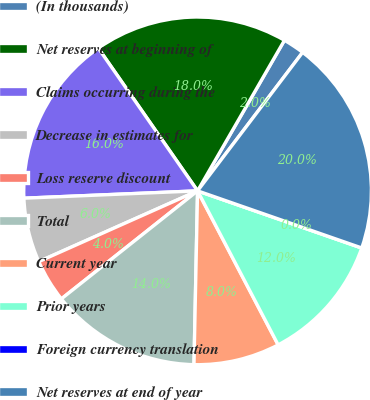Convert chart to OTSL. <chart><loc_0><loc_0><loc_500><loc_500><pie_chart><fcel>(In thousands)<fcel>Net reserves at beginning of<fcel>Claims occurring during the<fcel>Decrease in estimates for<fcel>Loss reserve discount<fcel>Total<fcel>Current year<fcel>Prior years<fcel>Foreign currency translation<fcel>Net reserves at end of year<nl><fcel>2.0%<fcel>18.0%<fcel>16.0%<fcel>6.0%<fcel>4.0%<fcel>14.0%<fcel>8.0%<fcel>12.0%<fcel>0.0%<fcel>20.0%<nl></chart> 